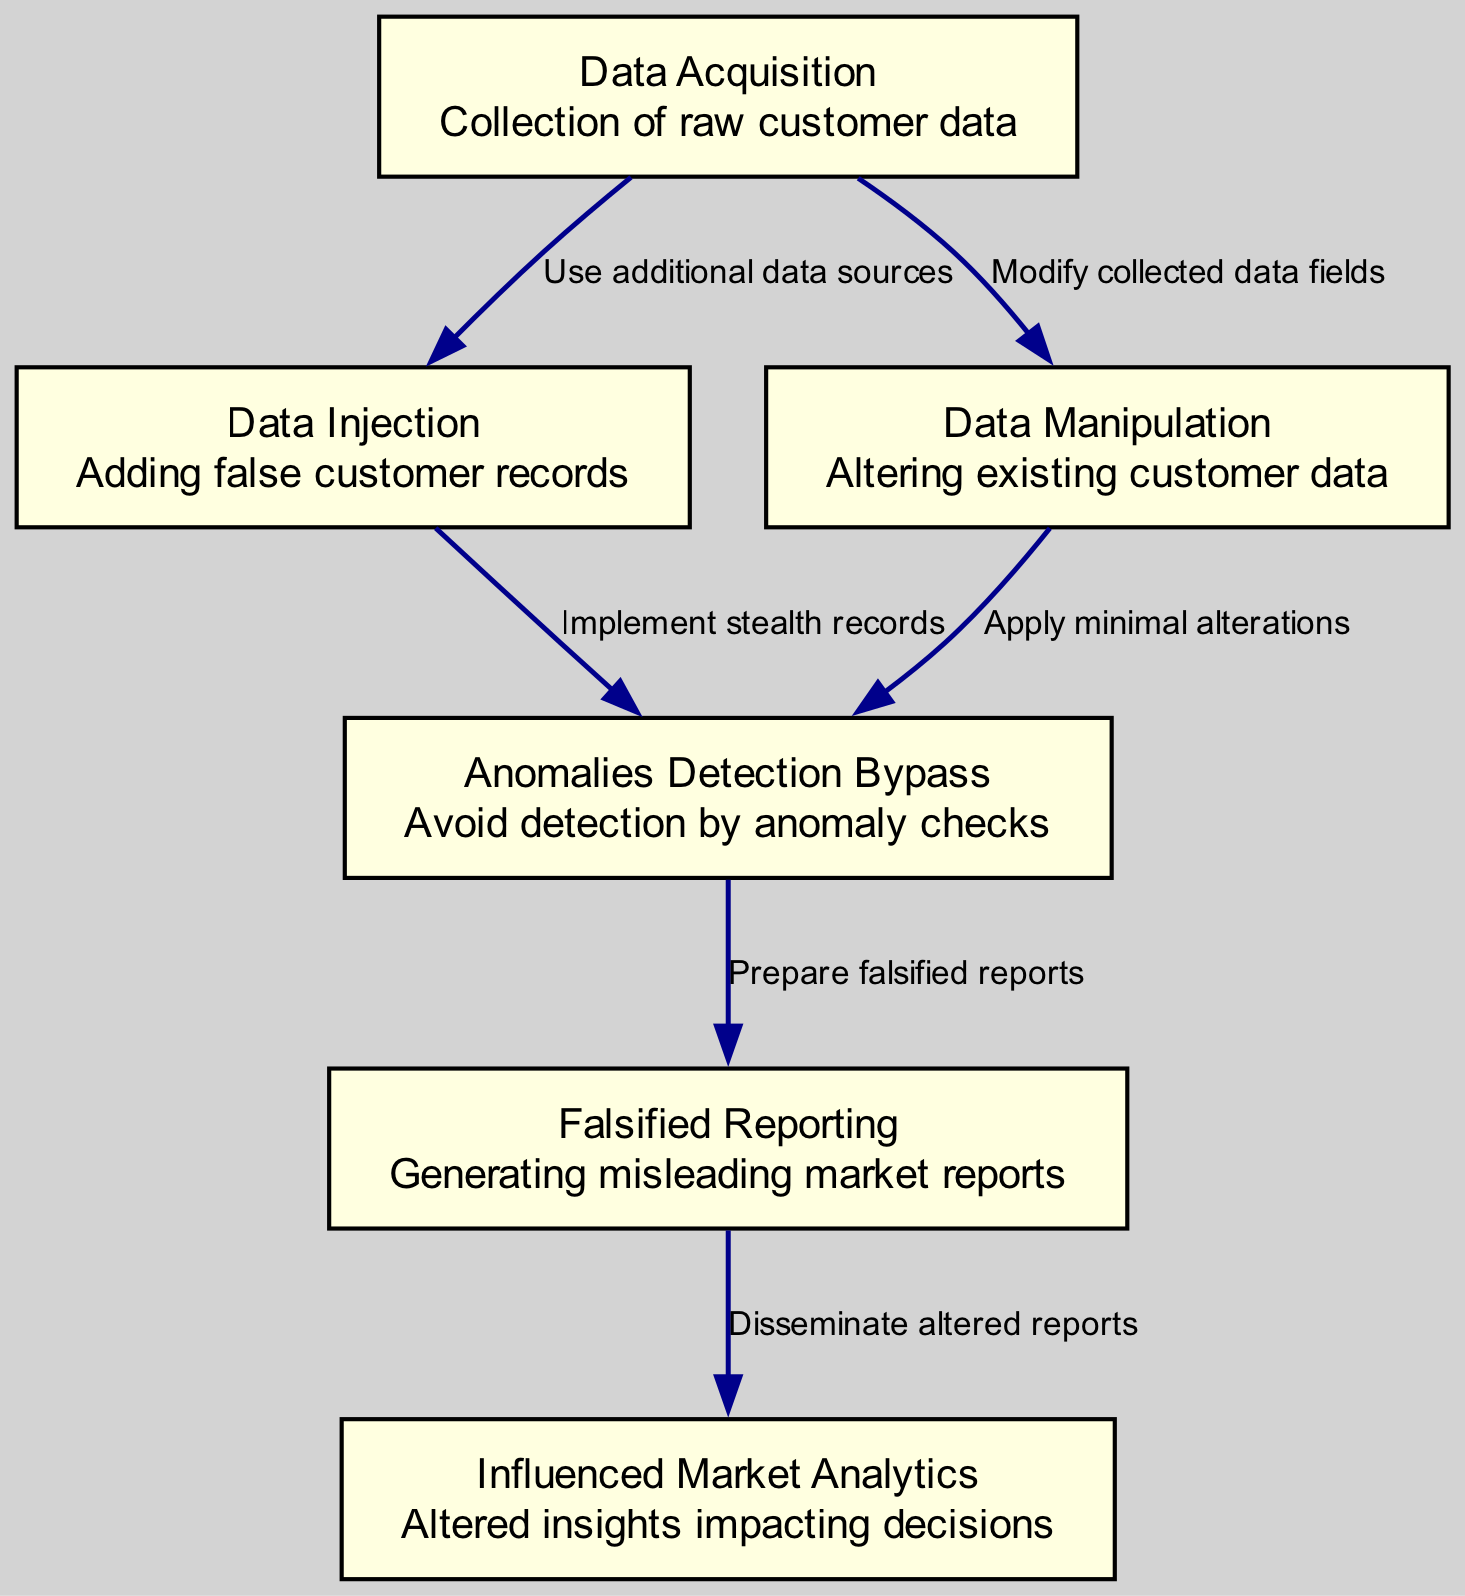What is the first step in data tampering? The diagram shows that the first step is "Data Acquisition," which involves the collection of raw customer data.
Answer: Data Acquisition How many nodes are present in the diagram? By counting the listed nodes in the data structure, we can see there are six nodes: Data Acquisition, Data Injection, Data Manipulation, Anomalies Detection Bypass, Falsified Reporting, and Influenced Market Analytics.
Answer: 6 What is the relationship between "Data Injection" and "Anomalies Detection Bypass"? The edge connecting "Data Injection" to "Anomalies Detection Bypass" indicates that "Implement stealth records" is the method used to avoid detection after injecting false customer records.
Answer: Implement stealth records Which step follows "Data Manipulation"? According to the diagram, after "Data Manipulation," the next step is "Anomalies Detection Bypass," indicating that data manipulation is designed to avoid detection of the changes made.
Answer: Anomalies Detection Bypass What is the final outcome of the process? The last node in the flow, "Influenced Market Analytics," represents the end result of all data tampering activities, showing that the tampered data ultimately impacts analytical insights.
Answer: Influenced Market Analytics How is misleading information generated in the reporting phase? The edge between "Anomalies Detection Bypass" and "Falsified Reporting" suggests that the step "Prepare falsified reports" is taken to create reports that mislead based on the manipulated data.
Answer: Prepare falsified reports What technique is used to minimize detection during "Data Manipulation"? The connection from "Data Manipulation" to "Anomalies Detection Bypass" indicates that "Apply minimal alterations" is the technique employed to ensure alterations do not trigger anomaly checks.
Answer: Apply minimal alterations What directly influences market analytics? The final part of the flow from "Falsified Reporting" to "Influenced Market Analytics" shows that the dissemination of altered reports makes them directly impact and influence market analytics.
Answer: Disseminate altered reports 